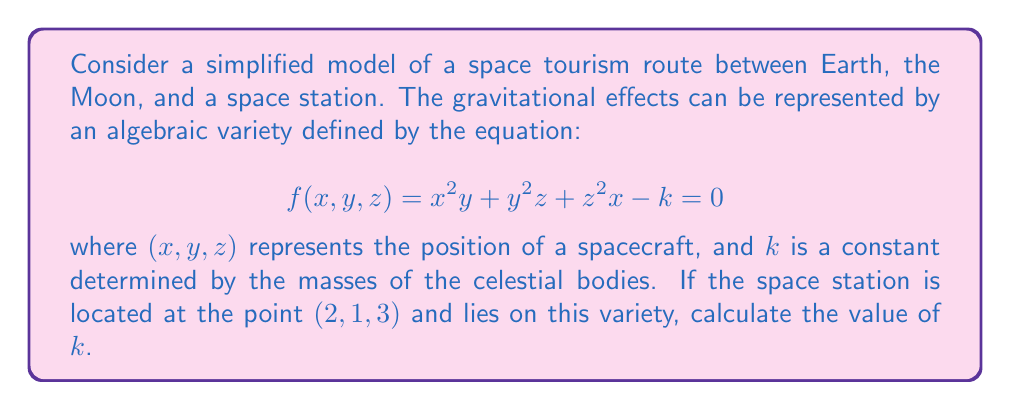Could you help me with this problem? To solve this problem, we'll follow these steps:

1) We're given that the space station is located at the point $(2,1,3)$ and lies on the variety. This means that these coordinates must satisfy the equation of the variety.

2) Let's substitute these values into the equation:

   $$f(2,1,3) = 2^2(1) + 1^2(3) + 3^2(2) - k = 0$$

3) Now, let's calculate each term:
   
   $2^2(1) = 4$
   $1^2(3) = 3$
   $3^2(2) = 18$

4) Substituting these values:

   $$4 + 3 + 18 - k = 0$$

5) Simplify:

   $$25 - k = 0$$

6) Solve for $k$:

   $$k = 25$$

Therefore, the value of the constant $k$ is 25.
Answer: $k = 25$ 